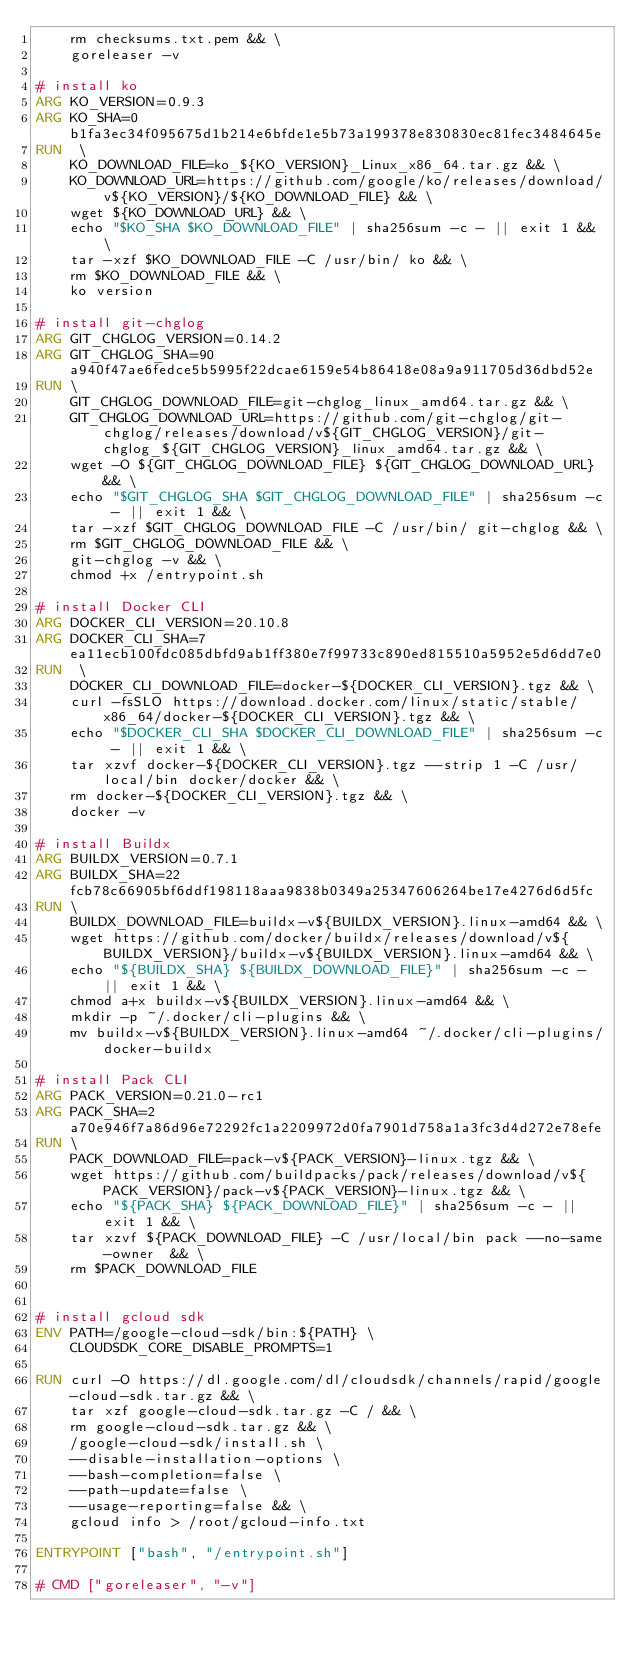Convert code to text. <code><loc_0><loc_0><loc_500><loc_500><_Dockerfile_>	rm checksums.txt.pem && \
	goreleaser -v

# install ko
ARG KO_VERSION=0.9.3
ARG KO_SHA=0b1fa3ec34f095675d1b214e6bfde1e5b73a199378e830830ec81fec3484645e
RUN  \
	KO_DOWNLOAD_FILE=ko_${KO_VERSION}_Linux_x86_64.tar.gz && \
	KO_DOWNLOAD_URL=https://github.com/google/ko/releases/download/v${KO_VERSION}/${KO_DOWNLOAD_FILE} && \
	wget ${KO_DOWNLOAD_URL} && \
	echo "$KO_SHA $KO_DOWNLOAD_FILE" | sha256sum -c - || exit 1 && \
	tar -xzf $KO_DOWNLOAD_FILE -C /usr/bin/ ko && \
	rm $KO_DOWNLOAD_FILE && \
	ko version

# install git-chglog
ARG GIT_CHGLOG_VERSION=0.14.2
ARG GIT_CHGLOG_SHA=90a940f47ae6fedce5b5995f22dcae6159e54b86418e08a9a911705d36dbd52e
RUN \
	GIT_CHGLOG_DOWNLOAD_FILE=git-chglog_linux_amd64.tar.gz && \
	GIT_CHGLOG_DOWNLOAD_URL=https://github.com/git-chglog/git-chglog/releases/download/v${GIT_CHGLOG_VERSION}/git-chglog_${GIT_CHGLOG_VERSION}_linux_amd64.tar.gz && \
	wget -O ${GIT_CHGLOG_DOWNLOAD_FILE} ${GIT_CHGLOG_DOWNLOAD_URL} && \
	echo "$GIT_CHGLOG_SHA $GIT_CHGLOG_DOWNLOAD_FILE" | sha256sum -c - || exit 1 && \
	tar -xzf $GIT_CHGLOG_DOWNLOAD_FILE -C /usr/bin/ git-chglog && \
	rm $GIT_CHGLOG_DOWNLOAD_FILE && \
	git-chglog -v && \
	chmod +x /entrypoint.sh

# install Docker CLI
ARG DOCKER_CLI_VERSION=20.10.8
ARG DOCKER_CLI_SHA=7ea11ecb100fdc085dbfd9ab1ff380e7f99733c890ed815510a5952e5d6dd7e0
RUN  \
    DOCKER_CLI_DOWNLOAD_FILE=docker-${DOCKER_CLI_VERSION}.tgz && \
    curl -fsSLO https://download.docker.com/linux/static/stable/x86_64/docker-${DOCKER_CLI_VERSION}.tgz && \
    echo "$DOCKER_CLI_SHA $DOCKER_CLI_DOWNLOAD_FILE" | sha256sum -c - || exit 1 && \
    tar xzvf docker-${DOCKER_CLI_VERSION}.tgz --strip 1 -C /usr/local/bin docker/docker && \
    rm docker-${DOCKER_CLI_VERSION}.tgz && \
    docker -v

# install Buildx
ARG BUILDX_VERSION=0.7.1
ARG BUILDX_SHA=22fcb78c66905bf6ddf198118aaa9838b0349a25347606264be17e4276d6d5fc
RUN \
    BUILDX_DOWNLOAD_FILE=buildx-v${BUILDX_VERSION}.linux-amd64 && \
    wget https://github.com/docker/buildx/releases/download/v${BUILDX_VERSION}/buildx-v${BUILDX_VERSION}.linux-amd64 && \
    echo "${BUILDX_SHA} ${BUILDX_DOWNLOAD_FILE}" | sha256sum -c - || exit 1 && \
    chmod a+x buildx-v${BUILDX_VERSION}.linux-amd64 && \
    mkdir -p ~/.docker/cli-plugins && \
    mv buildx-v${BUILDX_VERSION}.linux-amd64 ~/.docker/cli-plugins/docker-buildx

# install Pack CLI
ARG PACK_VERSION=0.21.0-rc1
ARG PACK_SHA=2a70e946f7a86d96e72292fc1a2209972d0fa7901d758a1a3fc3d4d272e78efe
RUN \
    PACK_DOWNLOAD_FILE=pack-v${PACK_VERSION}-linux.tgz && \
    wget https://github.com/buildpacks/pack/releases/download/v${PACK_VERSION}/pack-v${PACK_VERSION}-linux.tgz && \
    echo "${PACK_SHA} ${PACK_DOWNLOAD_FILE}" | sha256sum -c - || exit 1 && \
    tar xzvf ${PACK_DOWNLOAD_FILE} -C /usr/local/bin pack --no-same-owner  && \
	rm $PACK_DOWNLOAD_FILE


# install gcloud sdk
ENV PATH=/google-cloud-sdk/bin:${PATH} \
	CLOUDSDK_CORE_DISABLE_PROMPTS=1

RUN curl -O https://dl.google.com/dl/cloudsdk/channels/rapid/google-cloud-sdk.tar.gz && \
	tar xzf google-cloud-sdk.tar.gz -C / && \
	rm google-cloud-sdk.tar.gz && \
	/google-cloud-sdk/install.sh \
	--disable-installation-options \
	--bash-completion=false \
	--path-update=false \
	--usage-reporting=false && \
	gcloud info > /root/gcloud-info.txt

ENTRYPOINT ["bash", "/entrypoint.sh"]

# CMD ["goreleaser", "-v"]
</code> 